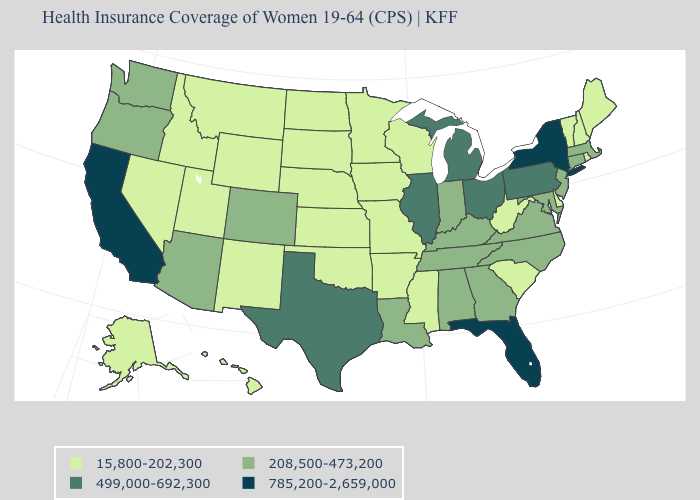Does California have the highest value in the West?
Short answer required. Yes. What is the value of Kansas?
Answer briefly. 15,800-202,300. Among the states that border Wyoming , which have the lowest value?
Write a very short answer. Idaho, Montana, Nebraska, South Dakota, Utah. Name the states that have a value in the range 15,800-202,300?
Quick response, please. Alaska, Arkansas, Delaware, Hawaii, Idaho, Iowa, Kansas, Maine, Minnesota, Mississippi, Missouri, Montana, Nebraska, Nevada, New Hampshire, New Mexico, North Dakota, Oklahoma, Rhode Island, South Carolina, South Dakota, Utah, Vermont, West Virginia, Wisconsin, Wyoming. Does Ohio have the highest value in the MidWest?
Concise answer only. Yes. Does Maine have the lowest value in the Northeast?
Concise answer only. Yes. Does Washington have the lowest value in the USA?
Quick response, please. No. Name the states that have a value in the range 208,500-473,200?
Write a very short answer. Alabama, Arizona, Colorado, Connecticut, Georgia, Indiana, Kentucky, Louisiana, Maryland, Massachusetts, New Jersey, North Carolina, Oregon, Tennessee, Virginia, Washington. What is the value of Illinois?
Write a very short answer. 499,000-692,300. Does Rhode Island have the same value as Indiana?
Answer briefly. No. What is the value of Oregon?
Write a very short answer. 208,500-473,200. Which states hav the highest value in the Northeast?
Short answer required. New York. What is the highest value in the South ?
Be succinct. 785,200-2,659,000. Name the states that have a value in the range 15,800-202,300?
Keep it brief. Alaska, Arkansas, Delaware, Hawaii, Idaho, Iowa, Kansas, Maine, Minnesota, Mississippi, Missouri, Montana, Nebraska, Nevada, New Hampshire, New Mexico, North Dakota, Oklahoma, Rhode Island, South Carolina, South Dakota, Utah, Vermont, West Virginia, Wisconsin, Wyoming. Among the states that border Arkansas , does Tennessee have the lowest value?
Be succinct. No. 